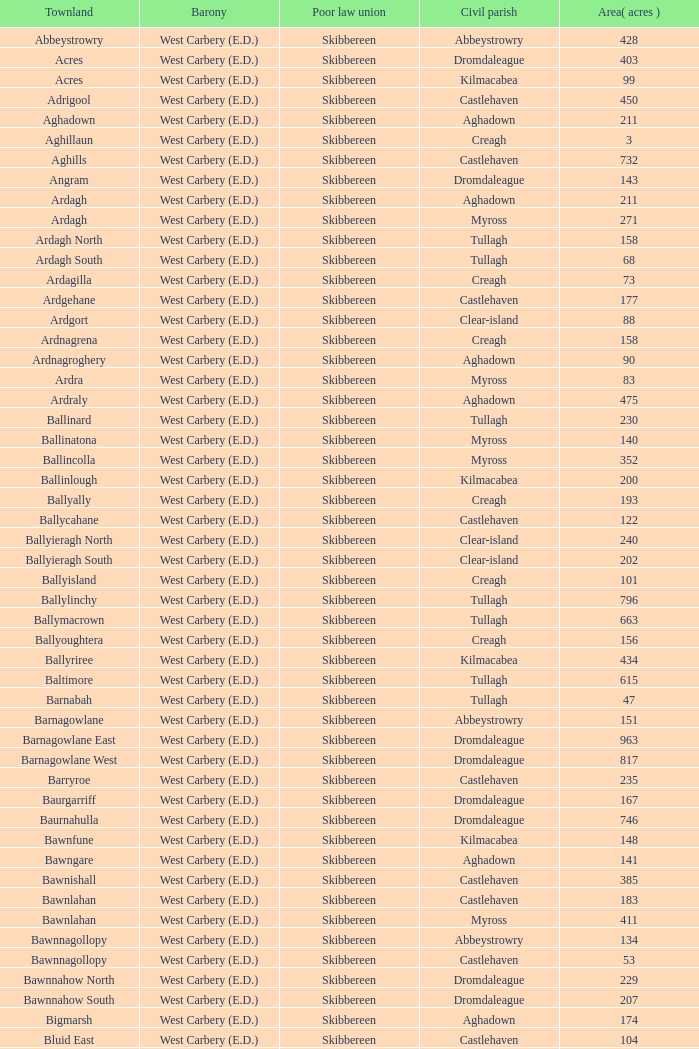What are the Poor Law Unions when the area (in acres) is 142? Skibbereen. 